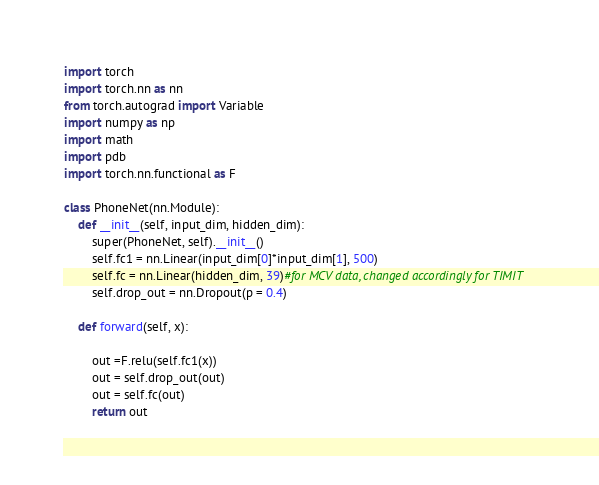Convert code to text. <code><loc_0><loc_0><loc_500><loc_500><_Python_>import torch 
import torch.nn as nn
from torch.autograd import Variable
import numpy as np
import math
import pdb
import torch.nn.functional as F

class PhoneNet(nn.Module):
	def __init__(self, input_dim, hidden_dim):
		super(PhoneNet, self).__init__()
		self.fc1 = nn.Linear(input_dim[0]*input_dim[1], 500)
		self.fc = nn.Linear(hidden_dim, 39)#for MCV data, changed accordingly for TIMIT
		self.drop_out = nn.Dropout(p = 0.4)

	def forward(self, x):

		out =F.relu(self.fc1(x))
		out = self.drop_out(out)
		out = self.fc(out)
		return out

</code> 